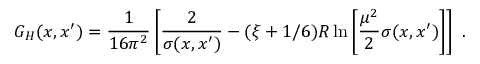<formula> <loc_0><loc_0><loc_500><loc_500>G _ { H } ( x , x ^ { \prime } ) = \frac { 1 } 1 6 \pi ^ { 2 } } \left [ \frac { 2 } \sigma ( x , x ^ { \prime } ) } - ( \xi + 1 / 6 ) R \ln \left [ \frac { \mu ^ { 2 } } 2 \sigma ( x , x ^ { \prime } ) \right ] \right ] \ .</formula> 